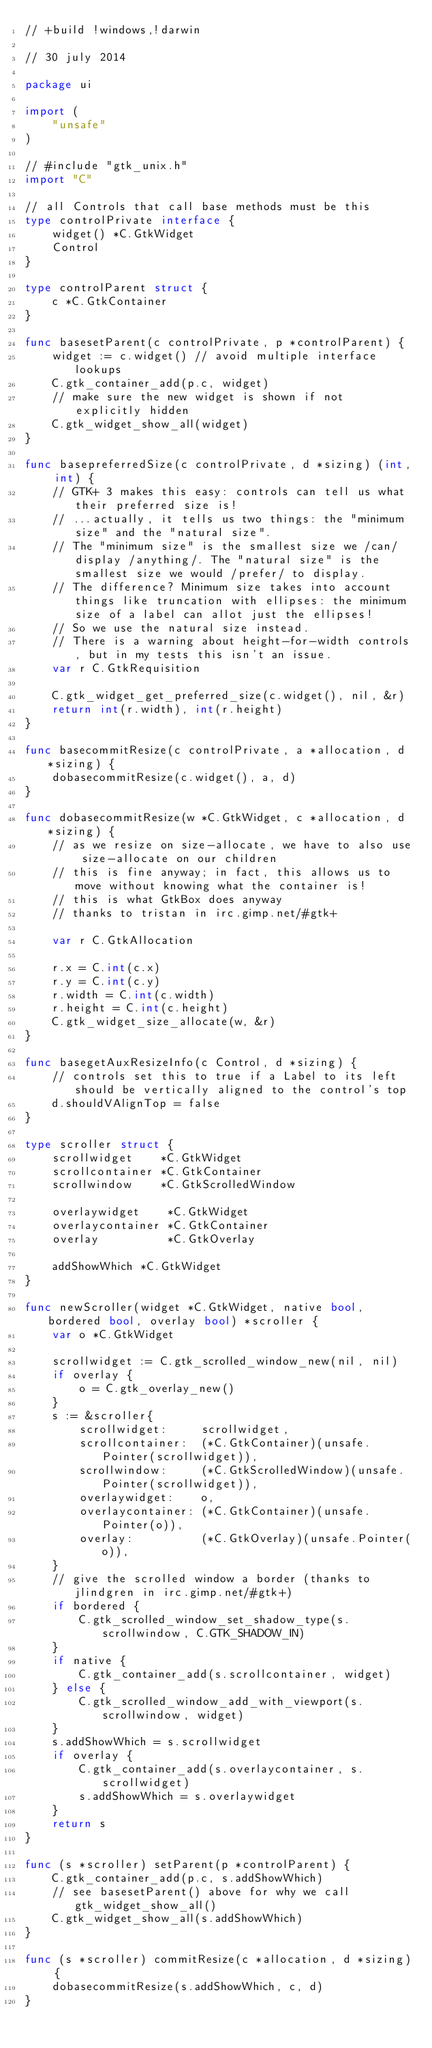Convert code to text. <code><loc_0><loc_0><loc_500><loc_500><_Go_>// +build !windows,!darwin

// 30 july 2014

package ui

import (
	"unsafe"
)

// #include "gtk_unix.h"
import "C"

// all Controls that call base methods must be this
type controlPrivate interface {
	widget() *C.GtkWidget
	Control
}

type controlParent struct {
	c *C.GtkContainer
}

func basesetParent(c controlPrivate, p *controlParent) {
	widget := c.widget() // avoid multiple interface lookups
	C.gtk_container_add(p.c, widget)
	// make sure the new widget is shown if not explicitly hidden
	C.gtk_widget_show_all(widget)
}

func basepreferredSize(c controlPrivate, d *sizing) (int, int) {
	// GTK+ 3 makes this easy: controls can tell us what their preferred size is!
	// ...actually, it tells us two things: the "minimum size" and the "natural size".
	// The "minimum size" is the smallest size we /can/ display /anything/. The "natural size" is the smallest size we would /prefer/ to display.
	// The difference? Minimum size takes into account things like truncation with ellipses: the minimum size of a label can allot just the ellipses!
	// So we use the natural size instead.
	// There is a warning about height-for-width controls, but in my tests this isn't an issue.
	var r C.GtkRequisition

	C.gtk_widget_get_preferred_size(c.widget(), nil, &r)
	return int(r.width), int(r.height)
}

func basecommitResize(c controlPrivate, a *allocation, d *sizing) {
	dobasecommitResize(c.widget(), a, d)
}

func dobasecommitResize(w *C.GtkWidget, c *allocation, d *sizing) {
	// as we resize on size-allocate, we have to also use size-allocate on our children
	// this is fine anyway; in fact, this allows us to move without knowing what the container is!
	// this is what GtkBox does anyway
	// thanks to tristan in irc.gimp.net/#gtk+

	var r C.GtkAllocation

	r.x = C.int(c.x)
	r.y = C.int(c.y)
	r.width = C.int(c.width)
	r.height = C.int(c.height)
	C.gtk_widget_size_allocate(w, &r)
}

func basegetAuxResizeInfo(c Control, d *sizing) {
	// controls set this to true if a Label to its left should be vertically aligned to the control's top
	d.shouldVAlignTop = false
}

type scroller struct {
	scrollwidget    *C.GtkWidget
	scrollcontainer *C.GtkContainer
	scrollwindow    *C.GtkScrolledWindow

	overlaywidget    *C.GtkWidget
	overlaycontainer *C.GtkContainer
	overlay          *C.GtkOverlay

	addShowWhich *C.GtkWidget
}

func newScroller(widget *C.GtkWidget, native bool, bordered bool, overlay bool) *scroller {
	var o *C.GtkWidget

	scrollwidget := C.gtk_scrolled_window_new(nil, nil)
	if overlay {
		o = C.gtk_overlay_new()
	}
	s := &scroller{
		scrollwidget:     scrollwidget,
		scrollcontainer:  (*C.GtkContainer)(unsafe.Pointer(scrollwidget)),
		scrollwindow:     (*C.GtkScrolledWindow)(unsafe.Pointer(scrollwidget)),
		overlaywidget:    o,
		overlaycontainer: (*C.GtkContainer)(unsafe.Pointer(o)),
		overlay:          (*C.GtkOverlay)(unsafe.Pointer(o)),
	}
	// give the scrolled window a border (thanks to jlindgren in irc.gimp.net/#gtk+)
	if bordered {
		C.gtk_scrolled_window_set_shadow_type(s.scrollwindow, C.GTK_SHADOW_IN)
	}
	if native {
		C.gtk_container_add(s.scrollcontainer, widget)
	} else {
		C.gtk_scrolled_window_add_with_viewport(s.scrollwindow, widget)
	}
	s.addShowWhich = s.scrollwidget
	if overlay {
		C.gtk_container_add(s.overlaycontainer, s.scrollwidget)
		s.addShowWhich = s.overlaywidget
	}
	return s
}

func (s *scroller) setParent(p *controlParent) {
	C.gtk_container_add(p.c, s.addShowWhich)
	// see basesetParent() above for why we call gtk_widget_show_all()
	C.gtk_widget_show_all(s.addShowWhich)
}

func (s *scroller) commitResize(c *allocation, d *sizing) {
	dobasecommitResize(s.addShowWhich, c, d)
}
</code> 